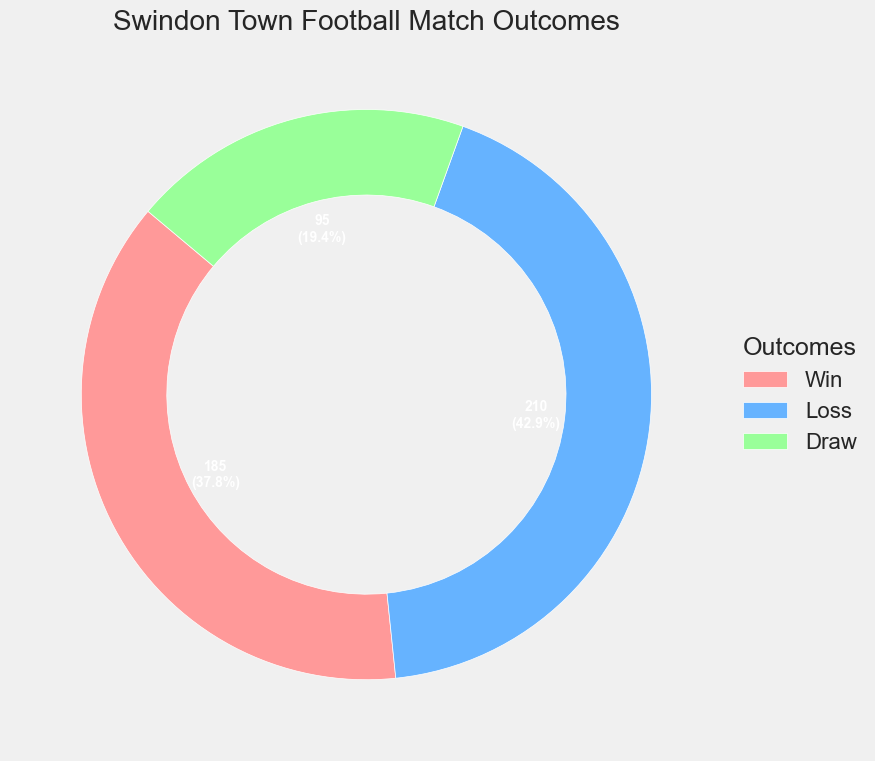What's the most common outcome for Swindon Town's football matches? The pie chart shows the distribution of match outcomes with both numbers and percentages. The largest segment corresponds to losses, indicating that losses are the most common outcome.
Answer: Losses What percentage of Swindon Town's football matches end in a draw? The pie chart displays both counts and percentages. The segment for draws shows "95\n(18.2%)".
Answer: 18.2% How much more frequent are wins than draws? The pie chart shows the counts for wins and draws. Wins are 185 and draws are 95. The difference is 185 - 95 = 90.
Answer: 90 How many more matches did Swindon Town lose compared to win? The pie chart displays the counts for losses and wins. Losses are 210 and wins are 185. The difference is 210 - 185 = 25.
Answer: 25 If you combined the wins and draws, what percentage of the total matches would that be? Wins are 185 and draws are 95. Adding them together gives 185 + 95 = 280. The total number of matches is 210 + 185 + 95 = 490. The percentage is (280/490) * 100 ≈ 57.1%.
Answer: 57.1% Which outcome is less than one-third of the total matches? One-third of the total matches is 490 / 3 ≈ 163.3. Both the count of draws (95) and wins (185) are mentioned. Draws are less than 163.3.
Answer: Draws What is the ratio of losses to total matches played? The total number of matches played is 490. The number of losses is 210. The ratio is 210/490 = 21/49, which simplifies to approximately 0.4286.
Answer: 0.4286 How do the sizes of the pie slices for wins and draws compare visually? From the pie chart, the slice for wins (185) is significantly larger than the slice for draws (95).
Answer: Wins are larger than draws What percentage of matches were not lost? The number of wins is 185 and draws is 95. Both combined are 185 + 95 = 280. The total matches are 490. The percentage is (280/490) * 100 ≈ 57.1%.
Answer: 57.1% If the number of draws doubled, how would this compare to the number of losses? If draws doubled, it would be 95 * 2 = 190. The number of losses is 210. 190 is less than 210 by 210 - 190 = 20.
Answer: 20 less 